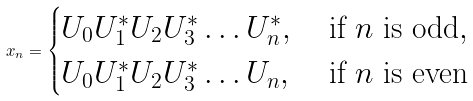Convert formula to latex. <formula><loc_0><loc_0><loc_500><loc_500>x _ { n } = \begin{cases} U _ { 0 } U _ { 1 } ^ { * } U _ { 2 } U _ { 3 } ^ { * } \hdots U _ { n } ^ { * } , & \text { if $n$ is odd} , \\ U _ { 0 } U _ { 1 } ^ { * } U _ { 2 } U _ { 3 } ^ { * } \hdots U _ { n } , & \text { if $n$ is even} \\ \end{cases}</formula> 